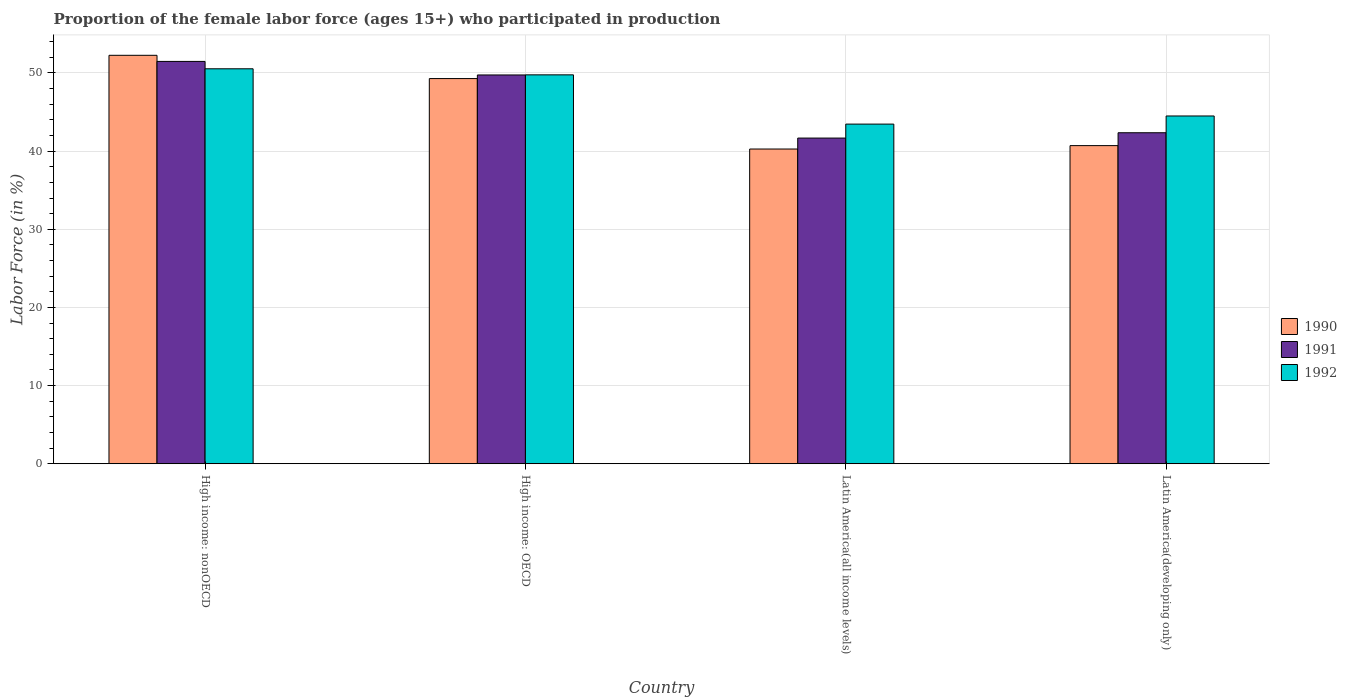How many different coloured bars are there?
Make the answer very short. 3. Are the number of bars on each tick of the X-axis equal?
Offer a very short reply. Yes. How many bars are there on the 4th tick from the left?
Keep it short and to the point. 3. What is the label of the 3rd group of bars from the left?
Keep it short and to the point. Latin America(all income levels). What is the proportion of the female labor force who participated in production in 1992 in High income: nonOECD?
Make the answer very short. 50.54. Across all countries, what is the maximum proportion of the female labor force who participated in production in 1992?
Keep it short and to the point. 50.54. Across all countries, what is the minimum proportion of the female labor force who participated in production in 1992?
Ensure brevity in your answer.  43.46. In which country was the proportion of the female labor force who participated in production in 1991 maximum?
Provide a succinct answer. High income: nonOECD. In which country was the proportion of the female labor force who participated in production in 1991 minimum?
Offer a terse response. Latin America(all income levels). What is the total proportion of the female labor force who participated in production in 1990 in the graph?
Provide a short and direct response. 182.52. What is the difference between the proportion of the female labor force who participated in production in 1991 in High income: nonOECD and that in Latin America(all income levels)?
Offer a very short reply. 9.81. What is the difference between the proportion of the female labor force who participated in production in 1992 in High income: nonOECD and the proportion of the female labor force who participated in production in 1991 in Latin America(developing only)?
Provide a short and direct response. 8.18. What is the average proportion of the female labor force who participated in production in 1992 per country?
Offer a very short reply. 47.06. What is the difference between the proportion of the female labor force who participated in production of/in 1990 and proportion of the female labor force who participated in production of/in 1992 in Latin America(developing only)?
Your answer should be compact. -3.79. In how many countries, is the proportion of the female labor force who participated in production in 1991 greater than 30 %?
Your response must be concise. 4. What is the ratio of the proportion of the female labor force who participated in production in 1990 in High income: nonOECD to that in Latin America(developing only)?
Offer a very short reply. 1.28. Is the difference between the proportion of the female labor force who participated in production in 1990 in High income: nonOECD and Latin America(all income levels) greater than the difference between the proportion of the female labor force who participated in production in 1992 in High income: nonOECD and Latin America(all income levels)?
Ensure brevity in your answer.  Yes. What is the difference between the highest and the second highest proportion of the female labor force who participated in production in 1992?
Keep it short and to the point. -0.78. What is the difference between the highest and the lowest proportion of the female labor force who participated in production in 1990?
Offer a terse response. 11.99. What does the 3rd bar from the left in Latin America(developing only) represents?
Give a very brief answer. 1992. How many bars are there?
Offer a terse response. 12. Are all the bars in the graph horizontal?
Offer a very short reply. No. Does the graph contain any zero values?
Provide a short and direct response. No. Where does the legend appear in the graph?
Ensure brevity in your answer.  Center right. What is the title of the graph?
Offer a very short reply. Proportion of the female labor force (ages 15+) who participated in production. What is the Labor Force (in %) of 1990 in High income: nonOECD?
Give a very brief answer. 52.26. What is the Labor Force (in %) in 1991 in High income: nonOECD?
Your response must be concise. 51.48. What is the Labor Force (in %) in 1992 in High income: nonOECD?
Provide a short and direct response. 50.54. What is the Labor Force (in %) in 1990 in High income: OECD?
Your answer should be compact. 49.29. What is the Labor Force (in %) in 1991 in High income: OECD?
Offer a very short reply. 49.75. What is the Labor Force (in %) in 1992 in High income: OECD?
Ensure brevity in your answer.  49.76. What is the Labor Force (in %) of 1990 in Latin America(all income levels)?
Make the answer very short. 40.27. What is the Labor Force (in %) in 1991 in Latin America(all income levels)?
Ensure brevity in your answer.  41.67. What is the Labor Force (in %) in 1992 in Latin America(all income levels)?
Your answer should be very brief. 43.46. What is the Labor Force (in %) of 1990 in Latin America(developing only)?
Provide a succinct answer. 40.71. What is the Labor Force (in %) of 1991 in Latin America(developing only)?
Give a very brief answer. 42.35. What is the Labor Force (in %) in 1992 in Latin America(developing only)?
Keep it short and to the point. 44.5. Across all countries, what is the maximum Labor Force (in %) of 1990?
Ensure brevity in your answer.  52.26. Across all countries, what is the maximum Labor Force (in %) of 1991?
Provide a short and direct response. 51.48. Across all countries, what is the maximum Labor Force (in %) in 1992?
Your response must be concise. 50.54. Across all countries, what is the minimum Labor Force (in %) of 1990?
Offer a very short reply. 40.27. Across all countries, what is the minimum Labor Force (in %) in 1991?
Your response must be concise. 41.67. Across all countries, what is the minimum Labor Force (in %) of 1992?
Ensure brevity in your answer.  43.46. What is the total Labor Force (in %) of 1990 in the graph?
Offer a terse response. 182.52. What is the total Labor Force (in %) in 1991 in the graph?
Offer a very short reply. 185.25. What is the total Labor Force (in %) of 1992 in the graph?
Your answer should be compact. 188.26. What is the difference between the Labor Force (in %) in 1990 in High income: nonOECD and that in High income: OECD?
Keep it short and to the point. 2.98. What is the difference between the Labor Force (in %) of 1991 in High income: nonOECD and that in High income: OECD?
Ensure brevity in your answer.  1.73. What is the difference between the Labor Force (in %) in 1992 in High income: nonOECD and that in High income: OECD?
Your response must be concise. 0.78. What is the difference between the Labor Force (in %) in 1990 in High income: nonOECD and that in Latin America(all income levels)?
Keep it short and to the point. 11.99. What is the difference between the Labor Force (in %) of 1991 in High income: nonOECD and that in Latin America(all income levels)?
Offer a terse response. 9.81. What is the difference between the Labor Force (in %) of 1992 in High income: nonOECD and that in Latin America(all income levels)?
Provide a short and direct response. 7.08. What is the difference between the Labor Force (in %) in 1990 in High income: nonOECD and that in Latin America(developing only)?
Your answer should be compact. 11.56. What is the difference between the Labor Force (in %) in 1991 in High income: nonOECD and that in Latin America(developing only)?
Give a very brief answer. 9.13. What is the difference between the Labor Force (in %) in 1992 in High income: nonOECD and that in Latin America(developing only)?
Offer a very short reply. 6.04. What is the difference between the Labor Force (in %) of 1990 in High income: OECD and that in Latin America(all income levels)?
Provide a succinct answer. 9.01. What is the difference between the Labor Force (in %) of 1991 in High income: OECD and that in Latin America(all income levels)?
Provide a succinct answer. 8.08. What is the difference between the Labor Force (in %) in 1992 in High income: OECD and that in Latin America(all income levels)?
Keep it short and to the point. 6.3. What is the difference between the Labor Force (in %) of 1990 in High income: OECD and that in Latin America(developing only)?
Make the answer very short. 8.58. What is the difference between the Labor Force (in %) in 1991 in High income: OECD and that in Latin America(developing only)?
Give a very brief answer. 7.39. What is the difference between the Labor Force (in %) in 1992 in High income: OECD and that in Latin America(developing only)?
Offer a terse response. 5.26. What is the difference between the Labor Force (in %) in 1990 in Latin America(all income levels) and that in Latin America(developing only)?
Your response must be concise. -0.43. What is the difference between the Labor Force (in %) in 1991 in Latin America(all income levels) and that in Latin America(developing only)?
Provide a succinct answer. -0.68. What is the difference between the Labor Force (in %) of 1992 in Latin America(all income levels) and that in Latin America(developing only)?
Your answer should be very brief. -1.04. What is the difference between the Labor Force (in %) in 1990 in High income: nonOECD and the Labor Force (in %) in 1991 in High income: OECD?
Your answer should be very brief. 2.52. What is the difference between the Labor Force (in %) of 1990 in High income: nonOECD and the Labor Force (in %) of 1992 in High income: OECD?
Give a very brief answer. 2.5. What is the difference between the Labor Force (in %) in 1991 in High income: nonOECD and the Labor Force (in %) in 1992 in High income: OECD?
Your response must be concise. 1.72. What is the difference between the Labor Force (in %) in 1990 in High income: nonOECD and the Labor Force (in %) in 1991 in Latin America(all income levels)?
Your answer should be very brief. 10.59. What is the difference between the Labor Force (in %) in 1990 in High income: nonOECD and the Labor Force (in %) in 1992 in Latin America(all income levels)?
Make the answer very short. 8.8. What is the difference between the Labor Force (in %) of 1991 in High income: nonOECD and the Labor Force (in %) of 1992 in Latin America(all income levels)?
Offer a very short reply. 8.02. What is the difference between the Labor Force (in %) in 1990 in High income: nonOECD and the Labor Force (in %) in 1991 in Latin America(developing only)?
Give a very brief answer. 9.91. What is the difference between the Labor Force (in %) of 1990 in High income: nonOECD and the Labor Force (in %) of 1992 in Latin America(developing only)?
Your answer should be compact. 7.76. What is the difference between the Labor Force (in %) in 1991 in High income: nonOECD and the Labor Force (in %) in 1992 in Latin America(developing only)?
Your answer should be very brief. 6.98. What is the difference between the Labor Force (in %) in 1990 in High income: OECD and the Labor Force (in %) in 1991 in Latin America(all income levels)?
Offer a very short reply. 7.61. What is the difference between the Labor Force (in %) of 1990 in High income: OECD and the Labor Force (in %) of 1992 in Latin America(all income levels)?
Keep it short and to the point. 5.82. What is the difference between the Labor Force (in %) of 1991 in High income: OECD and the Labor Force (in %) of 1992 in Latin America(all income levels)?
Provide a succinct answer. 6.29. What is the difference between the Labor Force (in %) in 1990 in High income: OECD and the Labor Force (in %) in 1991 in Latin America(developing only)?
Give a very brief answer. 6.93. What is the difference between the Labor Force (in %) in 1990 in High income: OECD and the Labor Force (in %) in 1992 in Latin America(developing only)?
Keep it short and to the point. 4.79. What is the difference between the Labor Force (in %) of 1991 in High income: OECD and the Labor Force (in %) of 1992 in Latin America(developing only)?
Provide a short and direct response. 5.25. What is the difference between the Labor Force (in %) of 1990 in Latin America(all income levels) and the Labor Force (in %) of 1991 in Latin America(developing only)?
Ensure brevity in your answer.  -2.08. What is the difference between the Labor Force (in %) of 1990 in Latin America(all income levels) and the Labor Force (in %) of 1992 in Latin America(developing only)?
Provide a short and direct response. -4.23. What is the difference between the Labor Force (in %) of 1991 in Latin America(all income levels) and the Labor Force (in %) of 1992 in Latin America(developing only)?
Provide a succinct answer. -2.83. What is the average Labor Force (in %) of 1990 per country?
Your response must be concise. 45.63. What is the average Labor Force (in %) in 1991 per country?
Keep it short and to the point. 46.31. What is the average Labor Force (in %) in 1992 per country?
Keep it short and to the point. 47.06. What is the difference between the Labor Force (in %) of 1990 and Labor Force (in %) of 1991 in High income: nonOECD?
Give a very brief answer. 0.78. What is the difference between the Labor Force (in %) in 1990 and Labor Force (in %) in 1992 in High income: nonOECD?
Your answer should be compact. 1.73. What is the difference between the Labor Force (in %) in 1991 and Labor Force (in %) in 1992 in High income: nonOECD?
Offer a terse response. 0.94. What is the difference between the Labor Force (in %) of 1990 and Labor Force (in %) of 1991 in High income: OECD?
Give a very brief answer. -0.46. What is the difference between the Labor Force (in %) of 1990 and Labor Force (in %) of 1992 in High income: OECD?
Offer a terse response. -0.48. What is the difference between the Labor Force (in %) in 1991 and Labor Force (in %) in 1992 in High income: OECD?
Offer a terse response. -0.01. What is the difference between the Labor Force (in %) in 1990 and Labor Force (in %) in 1991 in Latin America(all income levels)?
Make the answer very short. -1.4. What is the difference between the Labor Force (in %) of 1990 and Labor Force (in %) of 1992 in Latin America(all income levels)?
Give a very brief answer. -3.19. What is the difference between the Labor Force (in %) in 1991 and Labor Force (in %) in 1992 in Latin America(all income levels)?
Your answer should be very brief. -1.79. What is the difference between the Labor Force (in %) of 1990 and Labor Force (in %) of 1991 in Latin America(developing only)?
Ensure brevity in your answer.  -1.65. What is the difference between the Labor Force (in %) of 1990 and Labor Force (in %) of 1992 in Latin America(developing only)?
Ensure brevity in your answer.  -3.79. What is the difference between the Labor Force (in %) in 1991 and Labor Force (in %) in 1992 in Latin America(developing only)?
Your answer should be very brief. -2.14. What is the ratio of the Labor Force (in %) in 1990 in High income: nonOECD to that in High income: OECD?
Your response must be concise. 1.06. What is the ratio of the Labor Force (in %) in 1991 in High income: nonOECD to that in High income: OECD?
Your answer should be compact. 1.03. What is the ratio of the Labor Force (in %) in 1992 in High income: nonOECD to that in High income: OECD?
Ensure brevity in your answer.  1.02. What is the ratio of the Labor Force (in %) of 1990 in High income: nonOECD to that in Latin America(all income levels)?
Your answer should be very brief. 1.3. What is the ratio of the Labor Force (in %) in 1991 in High income: nonOECD to that in Latin America(all income levels)?
Provide a short and direct response. 1.24. What is the ratio of the Labor Force (in %) in 1992 in High income: nonOECD to that in Latin America(all income levels)?
Your answer should be compact. 1.16. What is the ratio of the Labor Force (in %) in 1990 in High income: nonOECD to that in Latin America(developing only)?
Ensure brevity in your answer.  1.28. What is the ratio of the Labor Force (in %) in 1991 in High income: nonOECD to that in Latin America(developing only)?
Ensure brevity in your answer.  1.22. What is the ratio of the Labor Force (in %) of 1992 in High income: nonOECD to that in Latin America(developing only)?
Provide a short and direct response. 1.14. What is the ratio of the Labor Force (in %) of 1990 in High income: OECD to that in Latin America(all income levels)?
Your answer should be compact. 1.22. What is the ratio of the Labor Force (in %) of 1991 in High income: OECD to that in Latin America(all income levels)?
Your response must be concise. 1.19. What is the ratio of the Labor Force (in %) in 1992 in High income: OECD to that in Latin America(all income levels)?
Offer a very short reply. 1.15. What is the ratio of the Labor Force (in %) in 1990 in High income: OECD to that in Latin America(developing only)?
Your answer should be compact. 1.21. What is the ratio of the Labor Force (in %) in 1991 in High income: OECD to that in Latin America(developing only)?
Offer a very short reply. 1.17. What is the ratio of the Labor Force (in %) of 1992 in High income: OECD to that in Latin America(developing only)?
Your answer should be compact. 1.12. What is the ratio of the Labor Force (in %) in 1990 in Latin America(all income levels) to that in Latin America(developing only)?
Ensure brevity in your answer.  0.99. What is the ratio of the Labor Force (in %) in 1991 in Latin America(all income levels) to that in Latin America(developing only)?
Provide a short and direct response. 0.98. What is the ratio of the Labor Force (in %) of 1992 in Latin America(all income levels) to that in Latin America(developing only)?
Keep it short and to the point. 0.98. What is the difference between the highest and the second highest Labor Force (in %) in 1990?
Keep it short and to the point. 2.98. What is the difference between the highest and the second highest Labor Force (in %) of 1991?
Offer a very short reply. 1.73. What is the difference between the highest and the second highest Labor Force (in %) in 1992?
Keep it short and to the point. 0.78. What is the difference between the highest and the lowest Labor Force (in %) of 1990?
Make the answer very short. 11.99. What is the difference between the highest and the lowest Labor Force (in %) in 1991?
Your response must be concise. 9.81. What is the difference between the highest and the lowest Labor Force (in %) in 1992?
Your answer should be very brief. 7.08. 